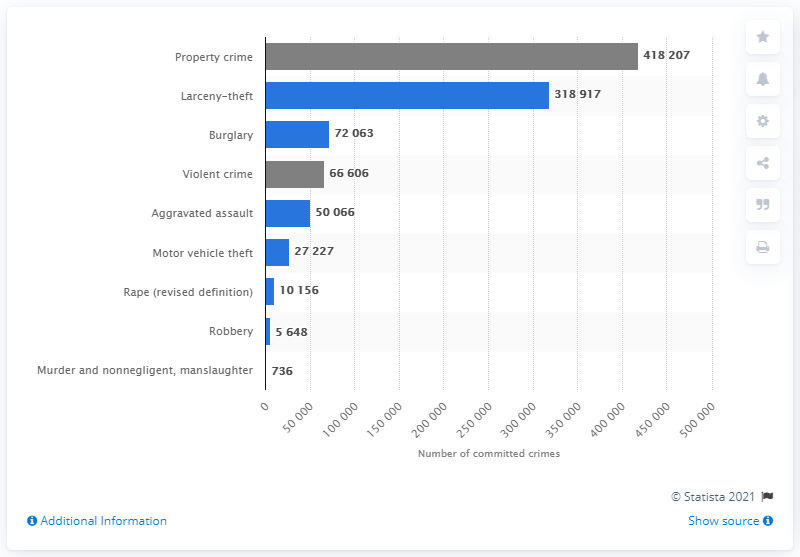Give some essential details in this illustration. In 2019, the FBI estimated that there were 736 cases of murder and non-negligent manslaughter outside of metropolitan areas. 